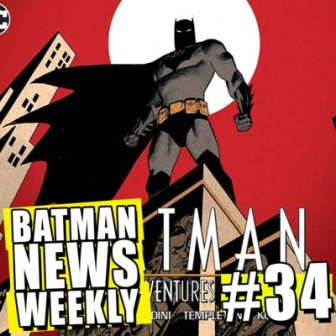What if Batman had to face a supernatural threat in this issue? How would the cover change? If Batman were to face a supernatural threat, the cover might take on a darker, more eerie tone. The red background could be replaced with a twilight sky, streaked with ominous clouds. Lightning could crackle in the distance, casting ghostly flashes over the scene. Batman’s silhouette might be surrounded by ethereal flames or shadowy figures, hinting at otherworldly adversaries. The building could be reimagined with ancient runes or mystical symbols glowing faintly around its edges. The overall composition would suggest an impending clash with forces beyond the mortal realm, adding a layer of supernatural intrigue to the issue. 